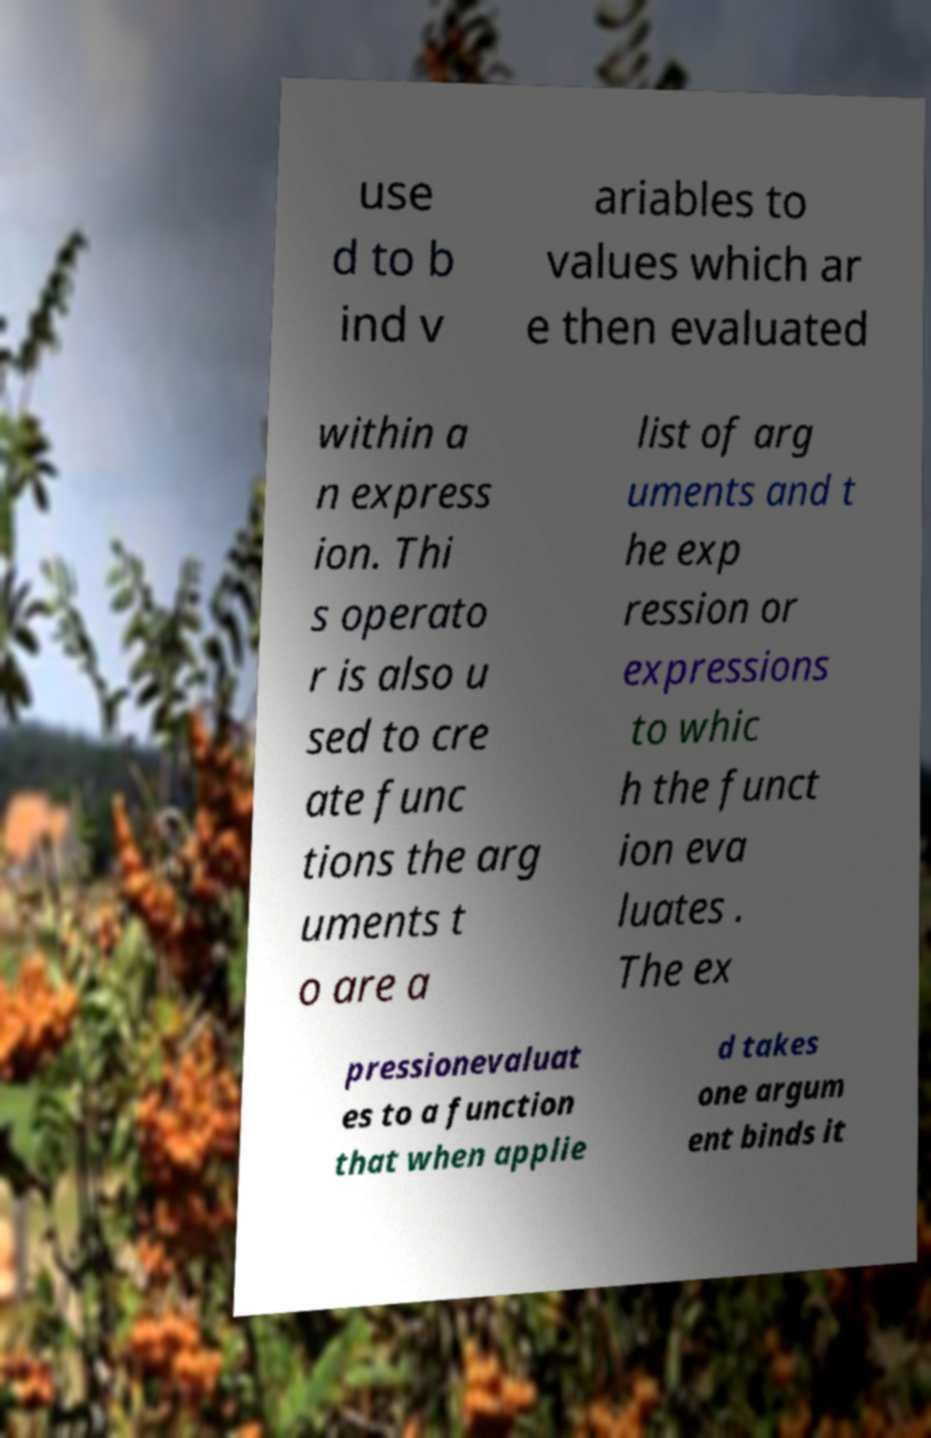What messages or text are displayed in this image? I need them in a readable, typed format. use d to b ind v ariables to values which ar e then evaluated within a n express ion. Thi s operato r is also u sed to cre ate func tions the arg uments t o are a list of arg uments and t he exp ression or expressions to whic h the funct ion eva luates . The ex pressionevaluat es to a function that when applie d takes one argum ent binds it 